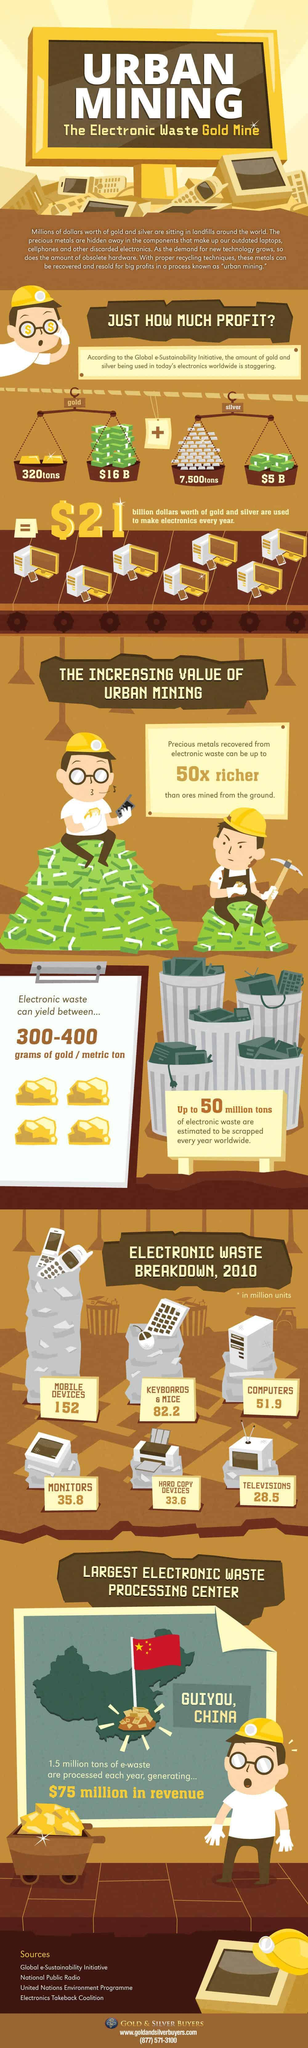Highlight a few significant elements in this photo. In today's electronics worldwide, an estimated 7,500 tons of silver is being used. In 2010, approximately 51.9 million units of computer e-waste were generated in the world. In 2010, mobile devices were the primary type of electronic waste produced in significant quantities. The largest electronic waste processing center in China is located in GUIYOU. An estimated $5 billion worth of silver is used to make electronics every year. 